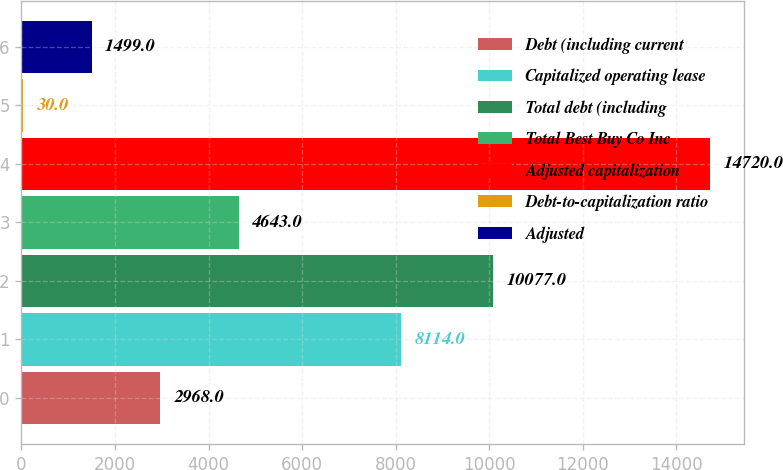Convert chart. <chart><loc_0><loc_0><loc_500><loc_500><bar_chart><fcel>Debt (including current<fcel>Capitalized operating lease<fcel>Total debt (including<fcel>Total Best Buy Co Inc<fcel>Adjusted capitalization<fcel>Debt-to-capitalization ratio<fcel>Adjusted<nl><fcel>2968<fcel>8114<fcel>10077<fcel>4643<fcel>14720<fcel>30<fcel>1499<nl></chart> 